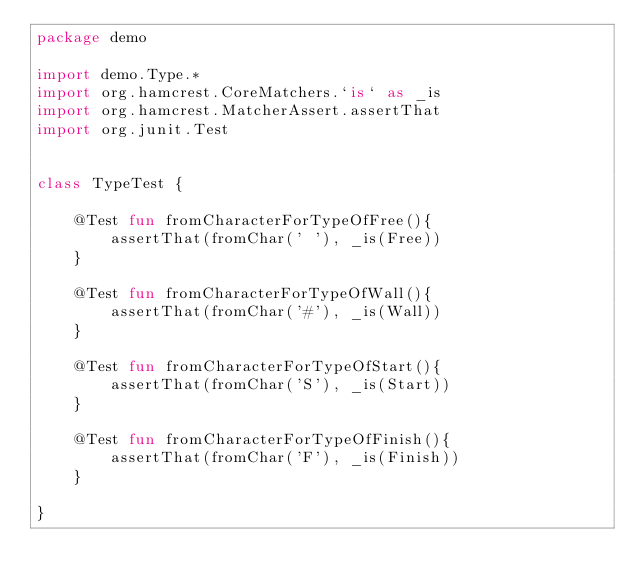<code> <loc_0><loc_0><loc_500><loc_500><_Kotlin_>package demo

import demo.Type.*
import org.hamcrest.CoreMatchers.`is` as _is
import org.hamcrest.MatcherAssert.assertThat
import org.junit.Test


class TypeTest {

    @Test fun fromCharacterForTypeOfFree(){
        assertThat(fromChar(' '), _is(Free))
    }

    @Test fun fromCharacterForTypeOfWall(){
        assertThat(fromChar('#'), _is(Wall))
    }

    @Test fun fromCharacterForTypeOfStart(){
        assertThat(fromChar('S'), _is(Start))
    }

    @Test fun fromCharacterForTypeOfFinish(){
        assertThat(fromChar('F'), _is(Finish))
    }

}
</code> 